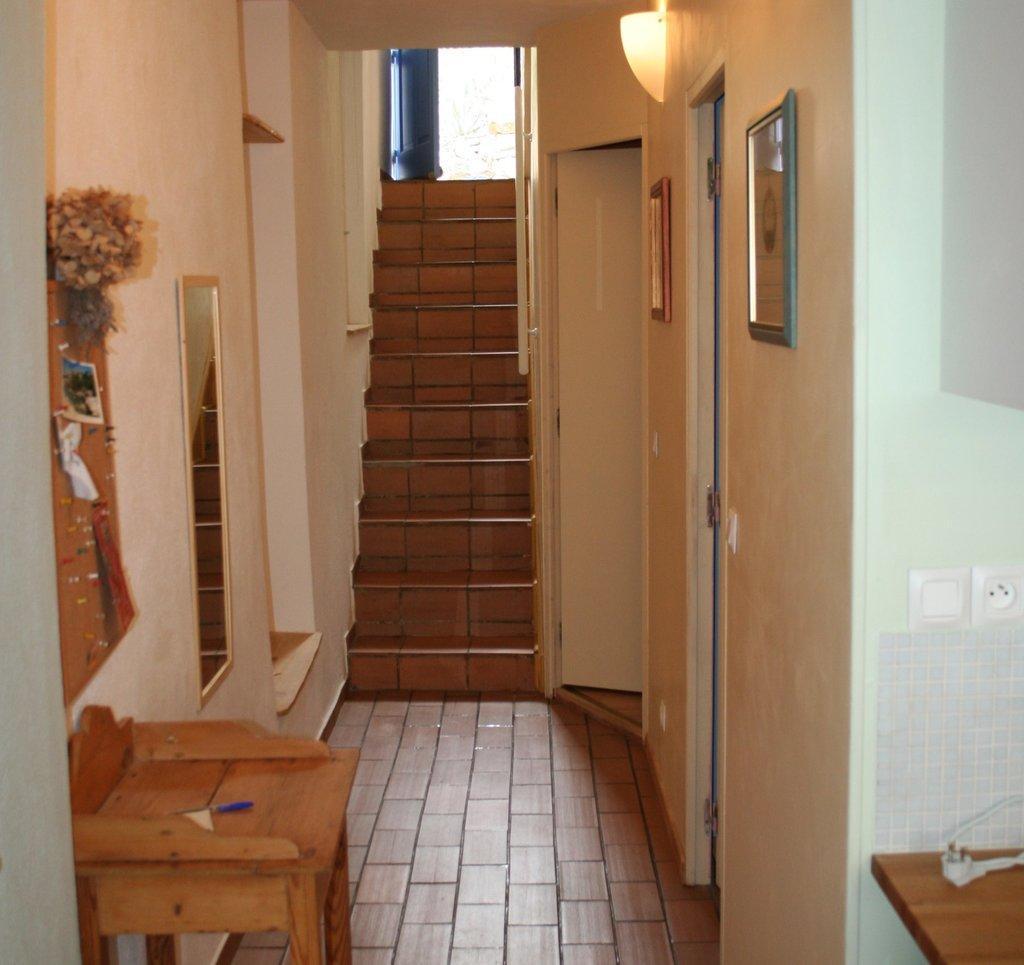How would you summarize this image in a sentence or two? In this picture I can see the stairs. I can see the mirror. I can see photo frames on the wall. I can see the table. I can see doors. 